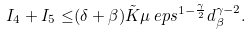Convert formula to latex. <formula><loc_0><loc_0><loc_500><loc_500>I _ { 4 } + I _ { 5 } \leq & ( \delta + \beta ) \tilde { K } \mu \ e p s ^ { 1 - \frac { \gamma } { 2 } } d _ { \beta } ^ { \gamma - 2 } .</formula> 